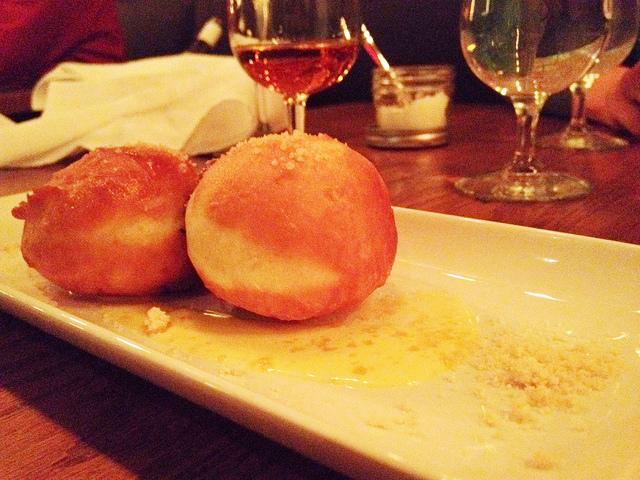Does the wine glass look empty?
Keep it brief. Yes. Are there two peaches in this shot?
Keep it brief. Yes. How many glasses do you see?
Be succinct. 3. Is that a white Zinfandel in the glass in the background?
Answer briefly. No. 